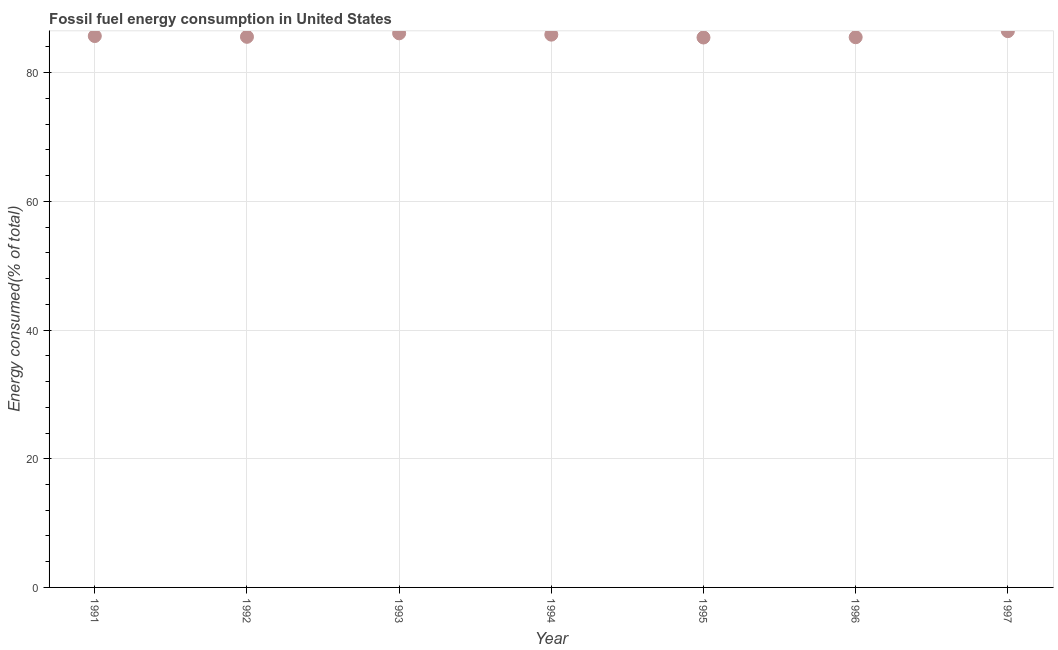What is the fossil fuel energy consumption in 1994?
Your response must be concise. 85.91. Across all years, what is the maximum fossil fuel energy consumption?
Offer a terse response. 86.46. Across all years, what is the minimum fossil fuel energy consumption?
Ensure brevity in your answer.  85.47. In which year was the fossil fuel energy consumption maximum?
Offer a terse response. 1997. What is the sum of the fossil fuel energy consumption?
Provide a short and direct response. 600.74. What is the difference between the fossil fuel energy consumption in 1993 and 1995?
Your response must be concise. 0.65. What is the average fossil fuel energy consumption per year?
Your answer should be very brief. 85.82. What is the median fossil fuel energy consumption?
Keep it short and to the point. 85.69. What is the ratio of the fossil fuel energy consumption in 1996 to that in 1997?
Ensure brevity in your answer.  0.99. Is the fossil fuel energy consumption in 1991 less than that in 1994?
Offer a terse response. Yes. Is the difference between the fossil fuel energy consumption in 1995 and 1996 greater than the difference between any two years?
Ensure brevity in your answer.  No. What is the difference between the highest and the second highest fossil fuel energy consumption?
Your answer should be compact. 0.34. Is the sum of the fossil fuel energy consumption in 1994 and 1996 greater than the maximum fossil fuel energy consumption across all years?
Your answer should be very brief. Yes. What is the difference between the highest and the lowest fossil fuel energy consumption?
Provide a succinct answer. 0.99. In how many years, is the fossil fuel energy consumption greater than the average fossil fuel energy consumption taken over all years?
Keep it short and to the point. 3. Does the graph contain grids?
Provide a succinct answer. Yes. What is the title of the graph?
Provide a succinct answer. Fossil fuel energy consumption in United States. What is the label or title of the Y-axis?
Keep it short and to the point. Energy consumed(% of total). What is the Energy consumed(% of total) in 1991?
Provide a short and direct response. 85.69. What is the Energy consumed(% of total) in 1992?
Keep it short and to the point. 85.57. What is the Energy consumed(% of total) in 1993?
Provide a succinct answer. 86.12. What is the Energy consumed(% of total) in 1994?
Your response must be concise. 85.91. What is the Energy consumed(% of total) in 1995?
Offer a terse response. 85.47. What is the Energy consumed(% of total) in 1996?
Provide a succinct answer. 85.51. What is the Energy consumed(% of total) in 1997?
Give a very brief answer. 86.46. What is the difference between the Energy consumed(% of total) in 1991 and 1992?
Provide a succinct answer. 0.12. What is the difference between the Energy consumed(% of total) in 1991 and 1993?
Your answer should be very brief. -0.42. What is the difference between the Energy consumed(% of total) in 1991 and 1994?
Your response must be concise. -0.22. What is the difference between the Energy consumed(% of total) in 1991 and 1995?
Your answer should be very brief. 0.23. What is the difference between the Energy consumed(% of total) in 1991 and 1996?
Offer a terse response. 0.18. What is the difference between the Energy consumed(% of total) in 1991 and 1997?
Provide a succinct answer. -0.76. What is the difference between the Energy consumed(% of total) in 1992 and 1993?
Offer a terse response. -0.54. What is the difference between the Energy consumed(% of total) in 1992 and 1994?
Your answer should be compact. -0.34. What is the difference between the Energy consumed(% of total) in 1992 and 1995?
Provide a short and direct response. 0.11. What is the difference between the Energy consumed(% of total) in 1992 and 1996?
Provide a short and direct response. 0.06. What is the difference between the Energy consumed(% of total) in 1992 and 1997?
Provide a short and direct response. -0.88. What is the difference between the Energy consumed(% of total) in 1993 and 1994?
Your answer should be very brief. 0.21. What is the difference between the Energy consumed(% of total) in 1993 and 1995?
Keep it short and to the point. 0.65. What is the difference between the Energy consumed(% of total) in 1993 and 1996?
Give a very brief answer. 0.61. What is the difference between the Energy consumed(% of total) in 1993 and 1997?
Make the answer very short. -0.34. What is the difference between the Energy consumed(% of total) in 1994 and 1995?
Make the answer very short. 0.44. What is the difference between the Energy consumed(% of total) in 1994 and 1996?
Keep it short and to the point. 0.4. What is the difference between the Energy consumed(% of total) in 1994 and 1997?
Give a very brief answer. -0.54. What is the difference between the Energy consumed(% of total) in 1995 and 1996?
Offer a terse response. -0.04. What is the difference between the Energy consumed(% of total) in 1995 and 1997?
Give a very brief answer. -0.99. What is the difference between the Energy consumed(% of total) in 1996 and 1997?
Offer a very short reply. -0.95. What is the ratio of the Energy consumed(% of total) in 1991 to that in 1992?
Your response must be concise. 1. What is the ratio of the Energy consumed(% of total) in 1991 to that in 1993?
Offer a very short reply. 0.99. What is the ratio of the Energy consumed(% of total) in 1991 to that in 1994?
Provide a succinct answer. 1. What is the ratio of the Energy consumed(% of total) in 1991 to that in 1995?
Give a very brief answer. 1. What is the ratio of the Energy consumed(% of total) in 1991 to that in 1996?
Keep it short and to the point. 1. What is the ratio of the Energy consumed(% of total) in 1991 to that in 1997?
Offer a terse response. 0.99. What is the ratio of the Energy consumed(% of total) in 1992 to that in 1993?
Ensure brevity in your answer.  0.99. What is the ratio of the Energy consumed(% of total) in 1993 to that in 1994?
Your response must be concise. 1. What is the ratio of the Energy consumed(% of total) in 1993 to that in 1995?
Give a very brief answer. 1.01. What is the ratio of the Energy consumed(% of total) in 1993 to that in 1997?
Provide a succinct answer. 1. What is the ratio of the Energy consumed(% of total) in 1994 to that in 1996?
Your answer should be very brief. 1. What is the ratio of the Energy consumed(% of total) in 1995 to that in 1996?
Provide a succinct answer. 1. 